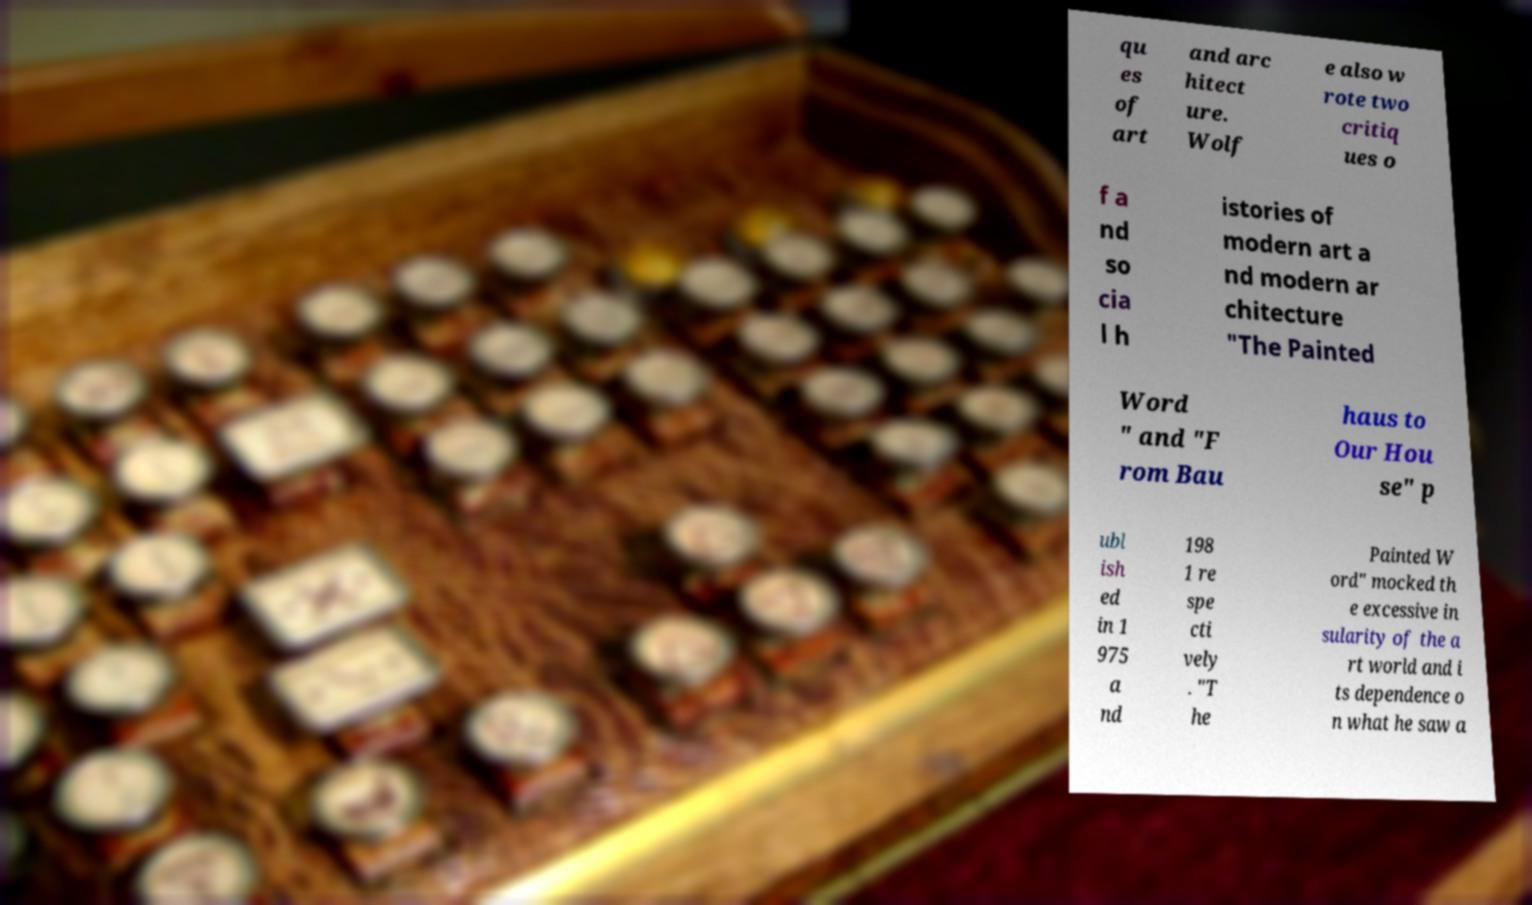Could you extract and type out the text from this image? qu es of art and arc hitect ure. Wolf e also w rote two critiq ues o f a nd so cia l h istories of modern art a nd modern ar chitecture "The Painted Word " and "F rom Bau haus to Our Hou se" p ubl ish ed in 1 975 a nd 198 1 re spe cti vely . "T he Painted W ord" mocked th e excessive in sularity of the a rt world and i ts dependence o n what he saw a 